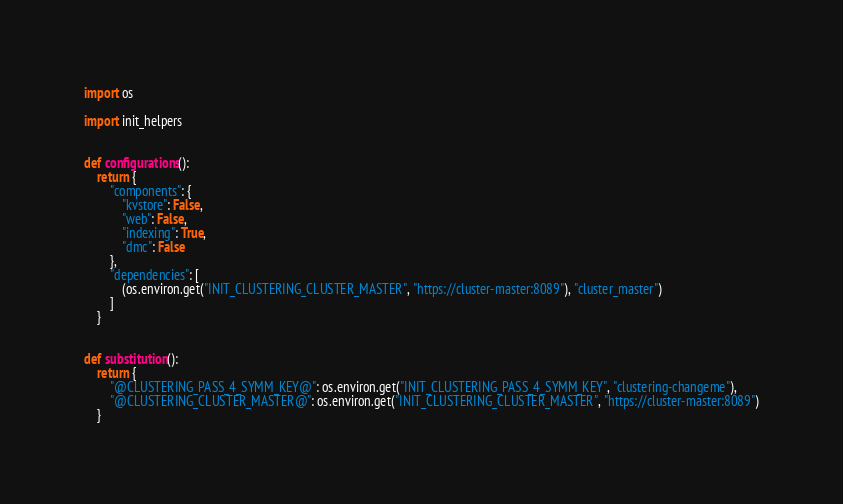<code> <loc_0><loc_0><loc_500><loc_500><_Python_>import os

import init_helpers


def configurations():
    return {
        "components": {
            "kvstore": False,
            "web": False,
            "indexing": True,
            "dmc": False
        },
        "dependencies": [
            (os.environ.get("INIT_CLUSTERING_CLUSTER_MASTER", "https://cluster-master:8089"), "cluster_master")
        ]
    }


def substitution():
    return {
        "@CLUSTERING_PASS_4_SYMM_KEY@": os.environ.get("INIT_CLUSTERING_PASS_4_SYMM_KEY", "clustering-changeme"),
        "@CLUSTERING_CLUSTER_MASTER@": os.environ.get("INIT_CLUSTERING_CLUSTER_MASTER", "https://cluster-master:8089")
    }
</code> 